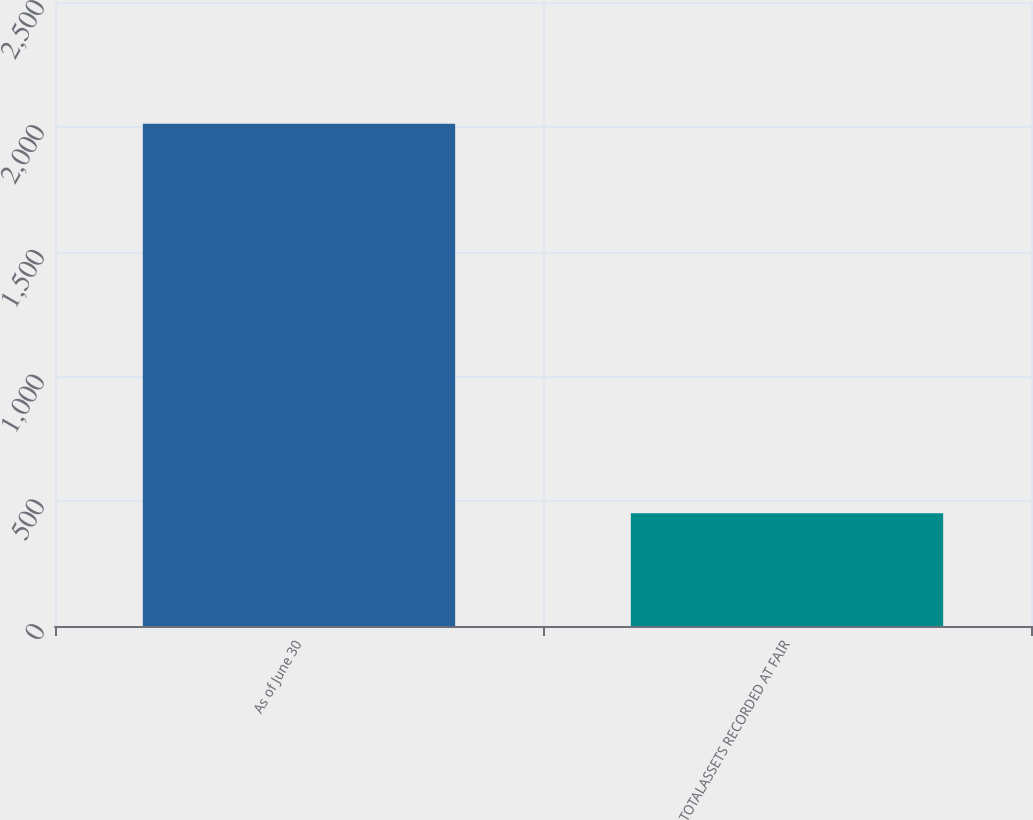<chart> <loc_0><loc_0><loc_500><loc_500><bar_chart><fcel>As of June 30<fcel>TOTALASSETS RECORDED AT FAIR<nl><fcel>2012<fcel>452<nl></chart> 